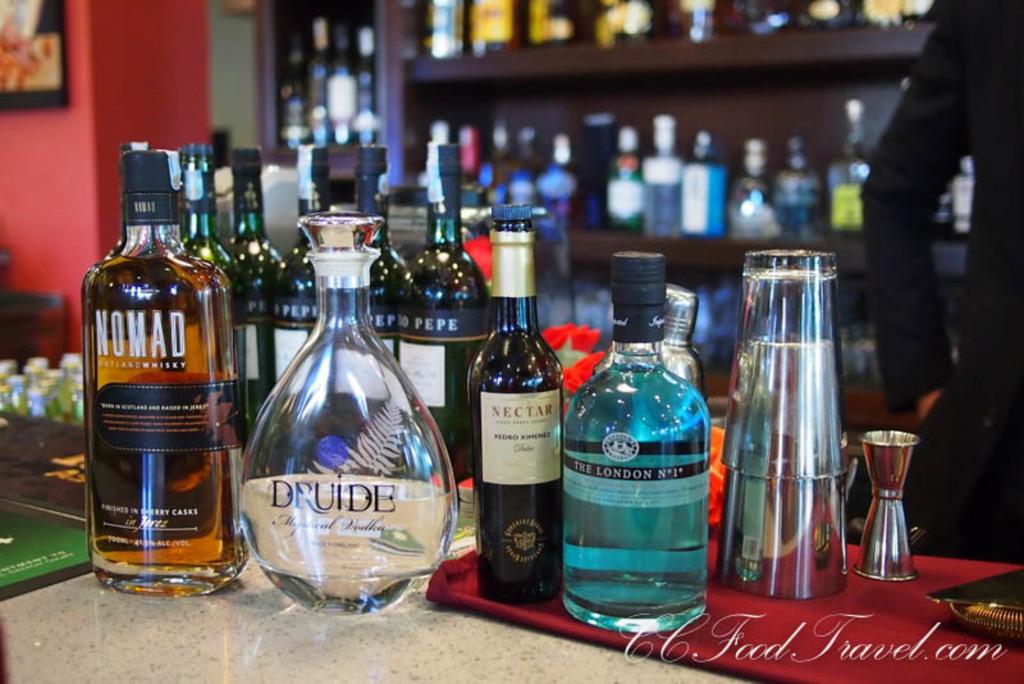What is the brand of the whisky on the left?
Make the answer very short. Nomad. What is the brand of the blue bottle?
Offer a very short reply. The london. 